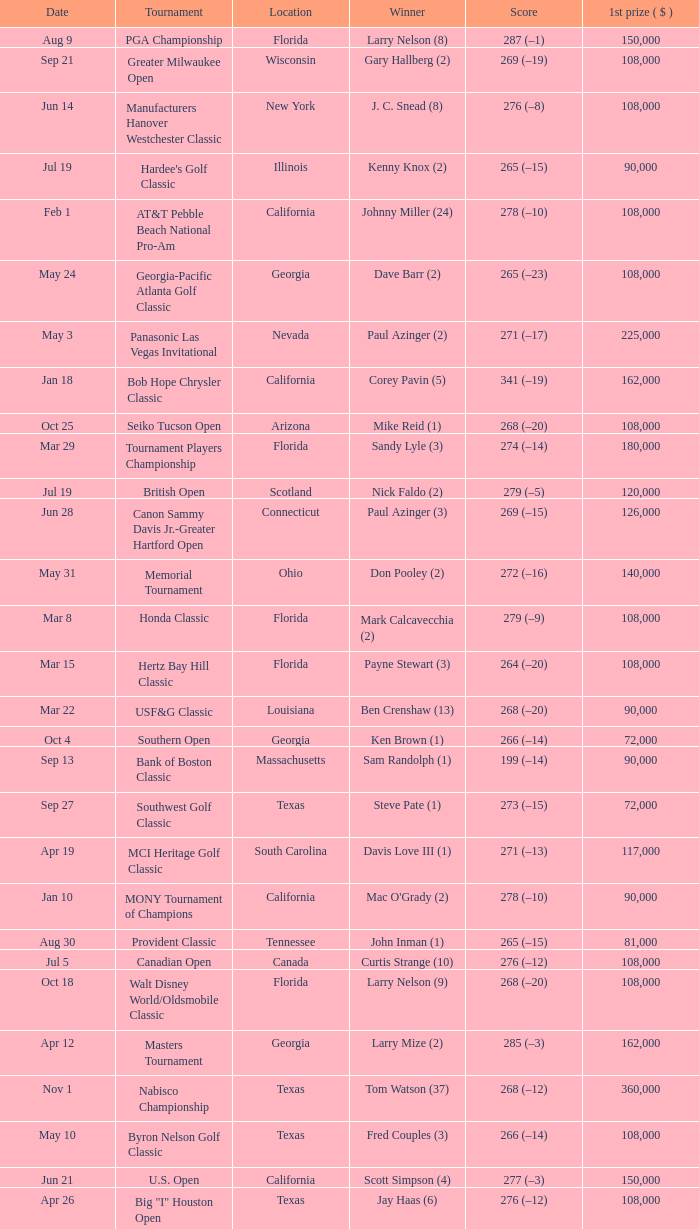What is the date where the winner was Tom Kite (10)? Jun 7. 